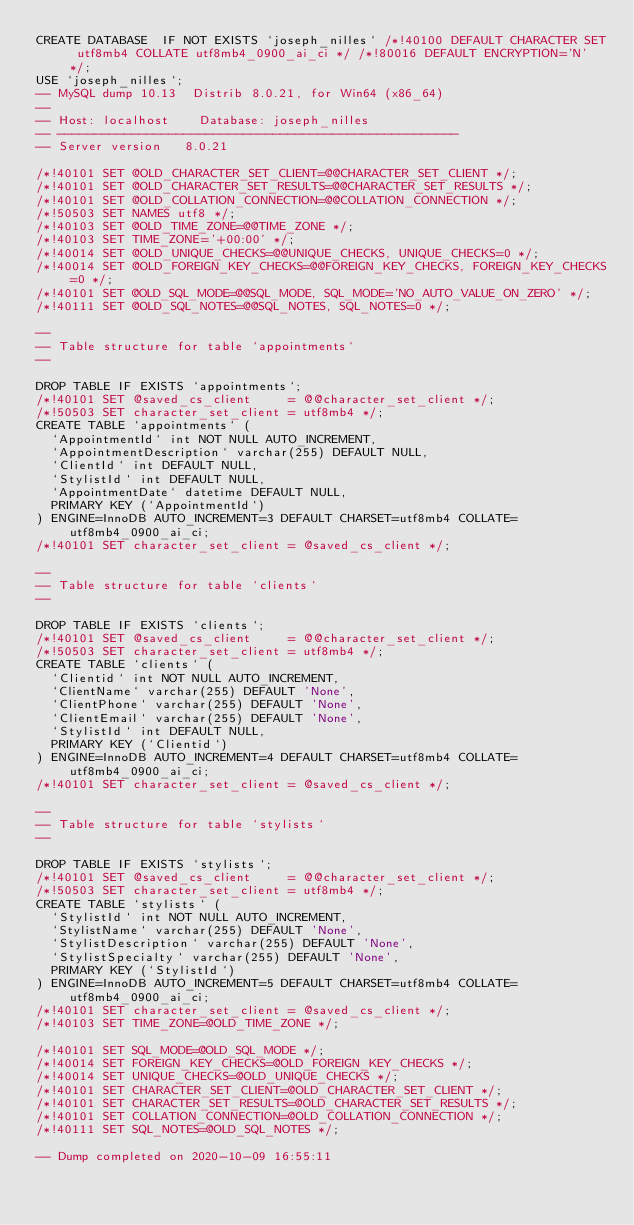Convert code to text. <code><loc_0><loc_0><loc_500><loc_500><_SQL_>CREATE DATABASE  IF NOT EXISTS `joseph_nilles` /*!40100 DEFAULT CHARACTER SET utf8mb4 COLLATE utf8mb4_0900_ai_ci */ /*!80016 DEFAULT ENCRYPTION='N' */;
USE `joseph_nilles`;
-- MySQL dump 10.13  Distrib 8.0.21, for Win64 (x86_64)
--
-- Host: localhost    Database: joseph_nilles
-- ------------------------------------------------------
-- Server version	8.0.21

/*!40101 SET @OLD_CHARACTER_SET_CLIENT=@@CHARACTER_SET_CLIENT */;
/*!40101 SET @OLD_CHARACTER_SET_RESULTS=@@CHARACTER_SET_RESULTS */;
/*!40101 SET @OLD_COLLATION_CONNECTION=@@COLLATION_CONNECTION */;
/*!50503 SET NAMES utf8 */;
/*!40103 SET @OLD_TIME_ZONE=@@TIME_ZONE */;
/*!40103 SET TIME_ZONE='+00:00' */;
/*!40014 SET @OLD_UNIQUE_CHECKS=@@UNIQUE_CHECKS, UNIQUE_CHECKS=0 */;
/*!40014 SET @OLD_FOREIGN_KEY_CHECKS=@@FOREIGN_KEY_CHECKS, FOREIGN_KEY_CHECKS=0 */;
/*!40101 SET @OLD_SQL_MODE=@@SQL_MODE, SQL_MODE='NO_AUTO_VALUE_ON_ZERO' */;
/*!40111 SET @OLD_SQL_NOTES=@@SQL_NOTES, SQL_NOTES=0 */;

--
-- Table structure for table `appointments`
--

DROP TABLE IF EXISTS `appointments`;
/*!40101 SET @saved_cs_client     = @@character_set_client */;
/*!50503 SET character_set_client = utf8mb4 */;
CREATE TABLE `appointments` (
  `AppointmentId` int NOT NULL AUTO_INCREMENT,
  `AppointmentDescription` varchar(255) DEFAULT NULL,
  `ClientId` int DEFAULT NULL,
  `StylistId` int DEFAULT NULL,
  `AppointmentDate` datetime DEFAULT NULL,
  PRIMARY KEY (`AppointmentId`)
) ENGINE=InnoDB AUTO_INCREMENT=3 DEFAULT CHARSET=utf8mb4 COLLATE=utf8mb4_0900_ai_ci;
/*!40101 SET character_set_client = @saved_cs_client */;

--
-- Table structure for table `clients`
--

DROP TABLE IF EXISTS `clients`;
/*!40101 SET @saved_cs_client     = @@character_set_client */;
/*!50503 SET character_set_client = utf8mb4 */;
CREATE TABLE `clients` (
  `Clientid` int NOT NULL AUTO_INCREMENT,
  `ClientName` varchar(255) DEFAULT 'None',
  `ClientPhone` varchar(255) DEFAULT 'None',
  `ClientEmail` varchar(255) DEFAULT 'None',
  `StylistId` int DEFAULT NULL,
  PRIMARY KEY (`Clientid`)
) ENGINE=InnoDB AUTO_INCREMENT=4 DEFAULT CHARSET=utf8mb4 COLLATE=utf8mb4_0900_ai_ci;
/*!40101 SET character_set_client = @saved_cs_client */;

--
-- Table structure for table `stylists`
--

DROP TABLE IF EXISTS `stylists`;
/*!40101 SET @saved_cs_client     = @@character_set_client */;
/*!50503 SET character_set_client = utf8mb4 */;
CREATE TABLE `stylists` (
  `StylistId` int NOT NULL AUTO_INCREMENT,
  `StylistName` varchar(255) DEFAULT 'None',
  `StylistDescription` varchar(255) DEFAULT 'None',
  `StylistSpecialty` varchar(255) DEFAULT 'None',
  PRIMARY KEY (`StylistId`)
) ENGINE=InnoDB AUTO_INCREMENT=5 DEFAULT CHARSET=utf8mb4 COLLATE=utf8mb4_0900_ai_ci;
/*!40101 SET character_set_client = @saved_cs_client */;
/*!40103 SET TIME_ZONE=@OLD_TIME_ZONE */;

/*!40101 SET SQL_MODE=@OLD_SQL_MODE */;
/*!40014 SET FOREIGN_KEY_CHECKS=@OLD_FOREIGN_KEY_CHECKS */;
/*!40014 SET UNIQUE_CHECKS=@OLD_UNIQUE_CHECKS */;
/*!40101 SET CHARACTER_SET_CLIENT=@OLD_CHARACTER_SET_CLIENT */;
/*!40101 SET CHARACTER_SET_RESULTS=@OLD_CHARACTER_SET_RESULTS */;
/*!40101 SET COLLATION_CONNECTION=@OLD_COLLATION_CONNECTION */;
/*!40111 SET SQL_NOTES=@OLD_SQL_NOTES */;

-- Dump completed on 2020-10-09 16:55:11
</code> 